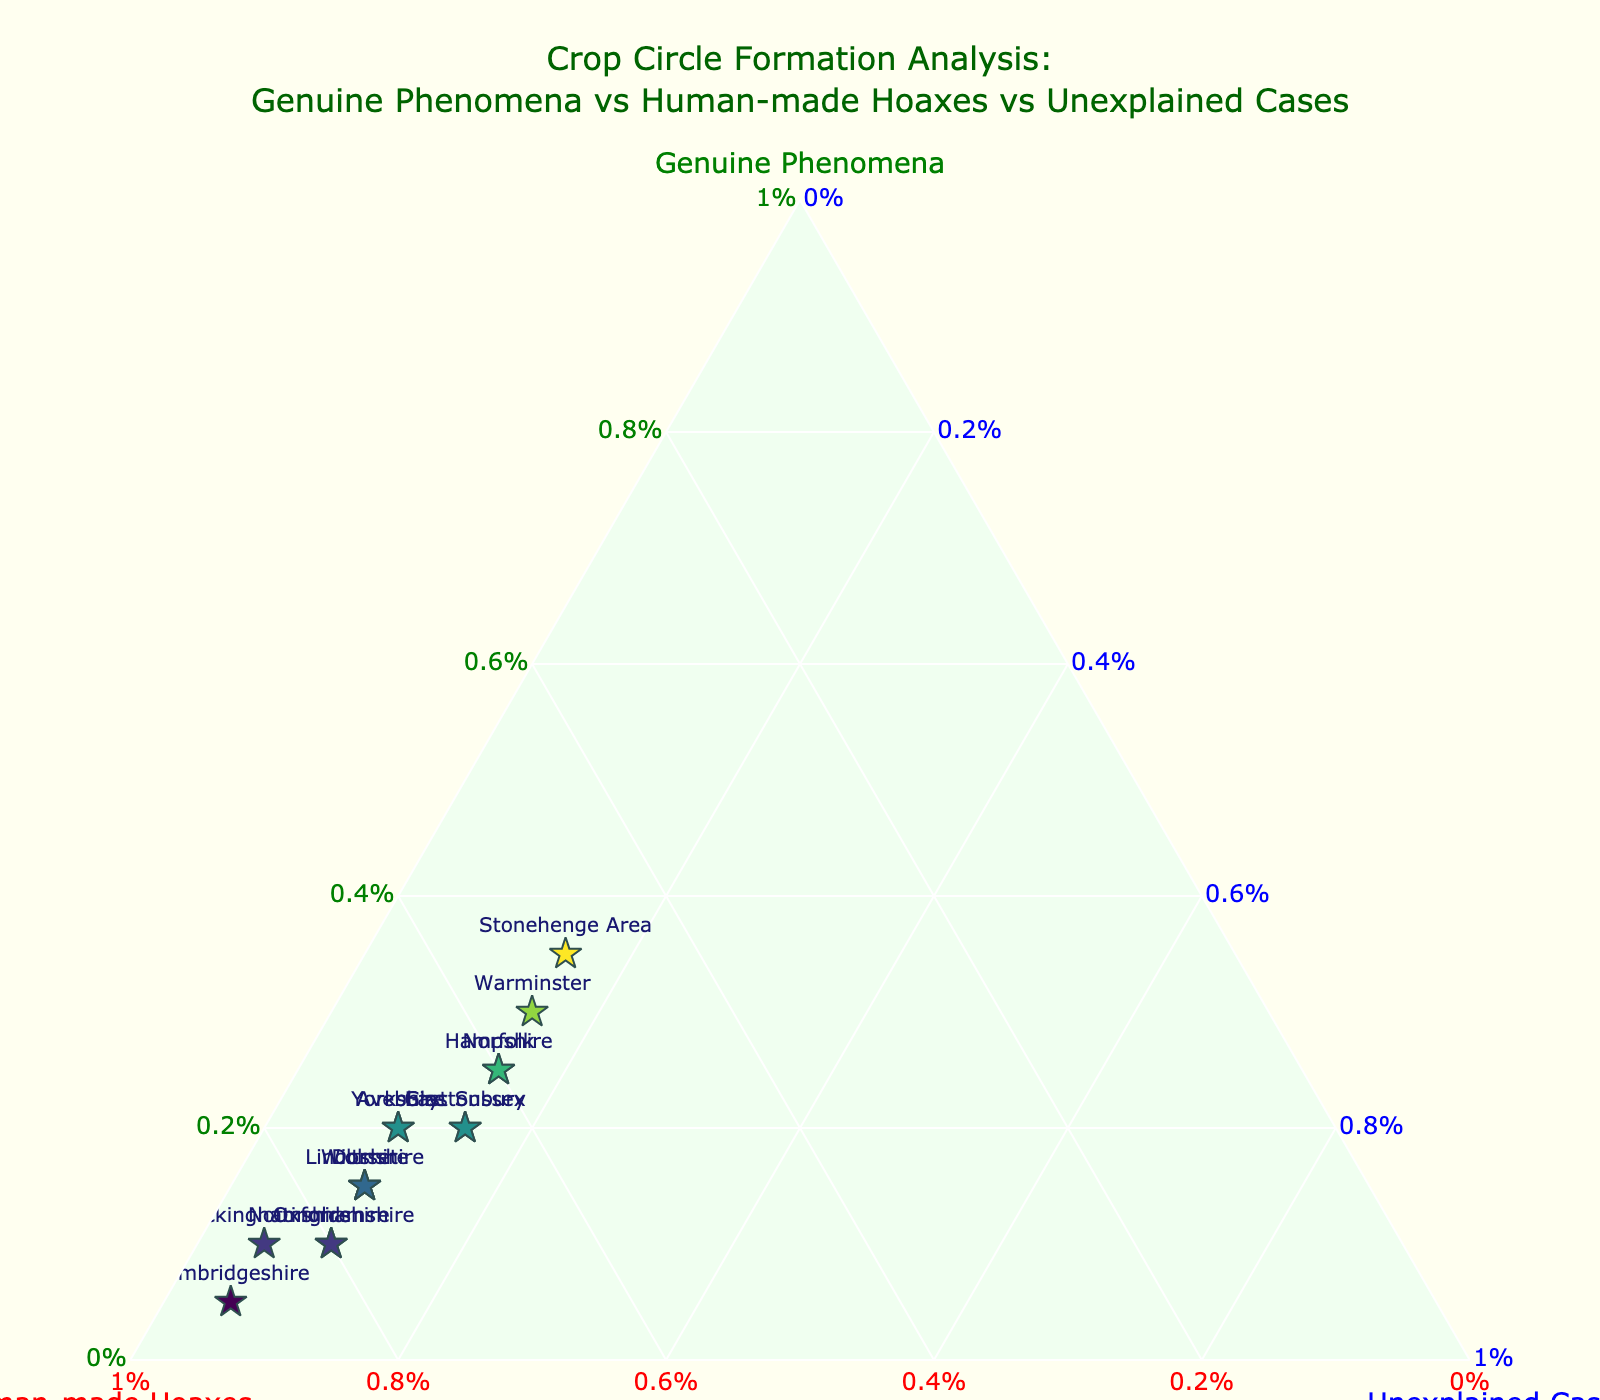What is the title of the ternary plot? The title is situated at the top of the plot and usually summarizes the main theme or subject of the data presented.
Answer: Crop Circle Formation Analysis: Genuine Phenomena vs Human-made Hoaxes vs Unexplained Cases How many locations are represented in the plot? Count the number of unique texts (or markers) displayed within the ternary diagram. Each marker corresponds to a unique location.
Answer: 15 Which location has the highest percentage of "Genuine Phenomena"? Look for the marker closest to the apex labeled "Genuine Phenomena." The text label next to this marker indicates the location.
Answer: Stonehenge Area What color is used for the "Genuine Phenomena" axis title? Examine the axis that has the label "Genuine Phenomena" and check the color of the text for this axis.
Answer: Green What is the percentage of "Unexplained Cases" in Buckinghamshire compared to Norfolk? Identify both locations on the plot and check the value at "Unexplained Cases" axis for each. Compute the difference in these percentages.
Answer: Buckinghamshire: 5%, Norfolk: 15%, Difference: 10% Which location has the smallest percentage of "Human-made Hoaxes"? Find the marker closest to the apex labeled "Genuine Phenomena" or "Unexplained Cases" and check its text label, then read its corresponding "Human-made Hoaxes" value.
Answer: Cambridgeshire What is the average percentage of "Unexplained Cases" for all locations? Sum the "Unexplained Cases" values for all locations and divide by the total number of locations. Detailed calculation: (10+15+10+15+15+15+10+10+5+15+5+15+10+10+10)/15 = 11.33
Answer: 11.33% Is there any location with equal percentages of "Genuine Phenomena" and "Unexplained Cases"? Scan for markers where the values for "Genuine Phenomena" and "Unexplained Cases" are identical according to the hover information or axis values.
Answer: None 